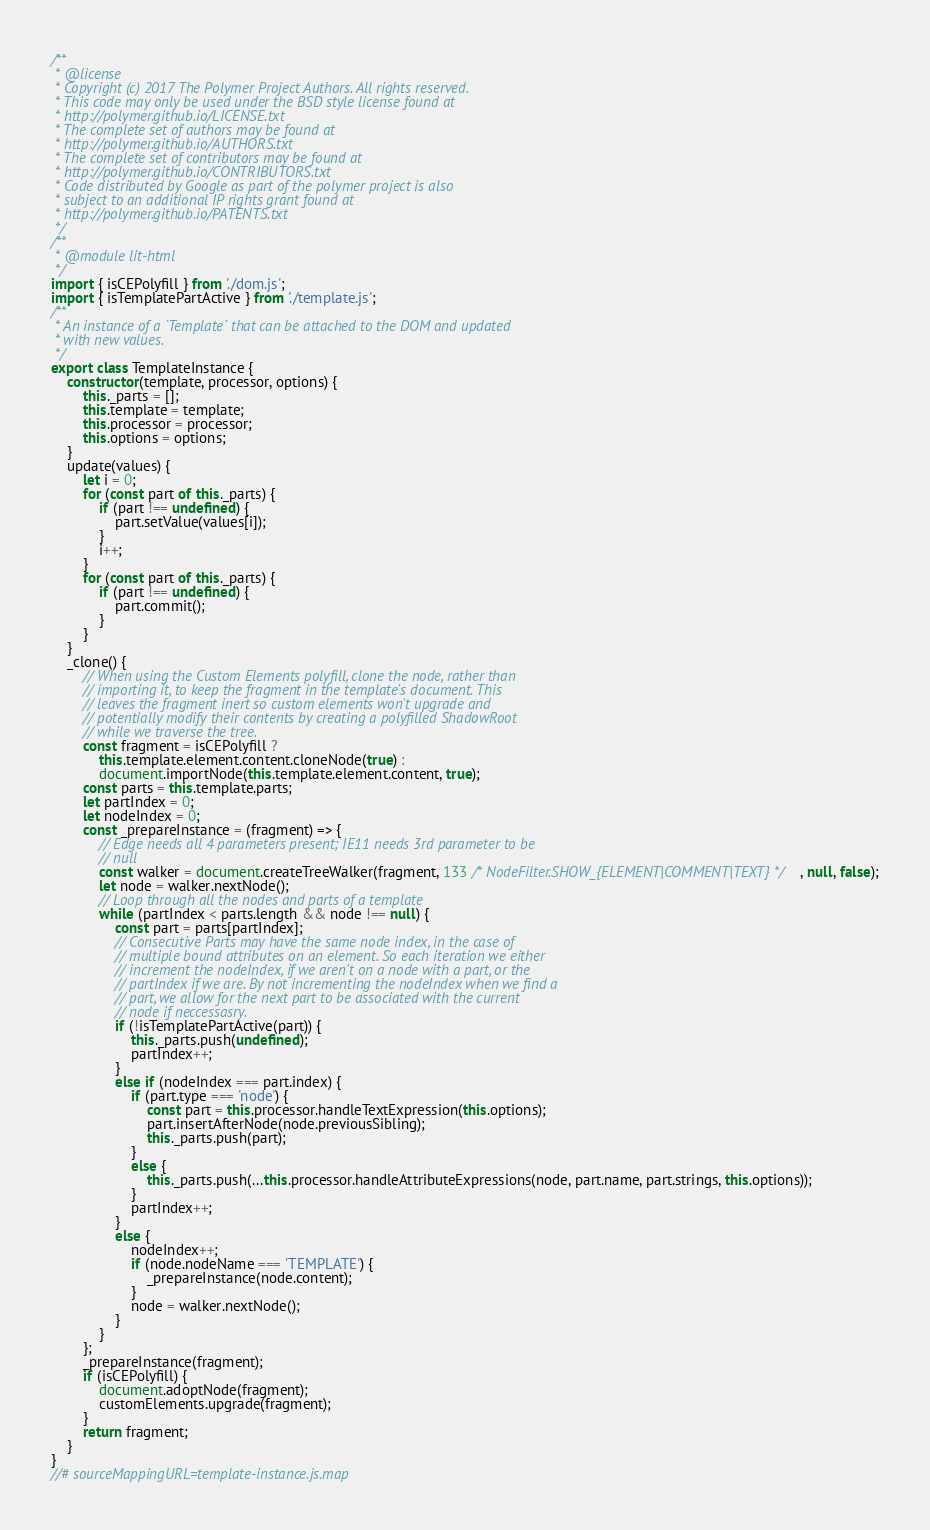<code> <loc_0><loc_0><loc_500><loc_500><_JavaScript_>/**
 * @license
 * Copyright (c) 2017 The Polymer Project Authors. All rights reserved.
 * This code may only be used under the BSD style license found at
 * http://polymer.github.io/LICENSE.txt
 * The complete set of authors may be found at
 * http://polymer.github.io/AUTHORS.txt
 * The complete set of contributors may be found at
 * http://polymer.github.io/CONTRIBUTORS.txt
 * Code distributed by Google as part of the polymer project is also
 * subject to an additional IP rights grant found at
 * http://polymer.github.io/PATENTS.txt
 */
/**
 * @module lit-html
 */
import { isCEPolyfill } from './dom.js';
import { isTemplatePartActive } from './template.js';
/**
 * An instance of a `Template` that can be attached to the DOM and updated
 * with new values.
 */
export class TemplateInstance {
    constructor(template, processor, options) {
        this._parts = [];
        this.template = template;
        this.processor = processor;
        this.options = options;
    }
    update(values) {
        let i = 0;
        for (const part of this._parts) {
            if (part !== undefined) {
                part.setValue(values[i]);
            }
            i++;
        }
        for (const part of this._parts) {
            if (part !== undefined) {
                part.commit();
            }
        }
    }
    _clone() {
        // When using the Custom Elements polyfill, clone the node, rather than
        // importing it, to keep the fragment in the template's document. This
        // leaves the fragment inert so custom elements won't upgrade and
        // potentially modify their contents by creating a polyfilled ShadowRoot
        // while we traverse the tree.
        const fragment = isCEPolyfill ?
            this.template.element.content.cloneNode(true) :
            document.importNode(this.template.element.content, true);
        const parts = this.template.parts;
        let partIndex = 0;
        let nodeIndex = 0;
        const _prepareInstance = (fragment) => {
            // Edge needs all 4 parameters present; IE11 needs 3rd parameter to be
            // null
            const walker = document.createTreeWalker(fragment, 133 /* NodeFilter.SHOW_{ELEMENT|COMMENT|TEXT} */, null, false);
            let node = walker.nextNode();
            // Loop through all the nodes and parts of a template
            while (partIndex < parts.length && node !== null) {
                const part = parts[partIndex];
                // Consecutive Parts may have the same node index, in the case of
                // multiple bound attributes on an element. So each iteration we either
                // increment the nodeIndex, if we aren't on a node with a part, or the
                // partIndex if we are. By not incrementing the nodeIndex when we find a
                // part, we allow for the next part to be associated with the current
                // node if neccessasry.
                if (!isTemplatePartActive(part)) {
                    this._parts.push(undefined);
                    partIndex++;
                }
                else if (nodeIndex === part.index) {
                    if (part.type === 'node') {
                        const part = this.processor.handleTextExpression(this.options);
                        part.insertAfterNode(node.previousSibling);
                        this._parts.push(part);
                    }
                    else {
                        this._parts.push(...this.processor.handleAttributeExpressions(node, part.name, part.strings, this.options));
                    }
                    partIndex++;
                }
                else {
                    nodeIndex++;
                    if (node.nodeName === 'TEMPLATE') {
                        _prepareInstance(node.content);
                    }
                    node = walker.nextNode();
                }
            }
        };
        _prepareInstance(fragment);
        if (isCEPolyfill) {
            document.adoptNode(fragment);
            customElements.upgrade(fragment);
        }
        return fragment;
    }
}
//# sourceMappingURL=template-instance.js.map</code> 